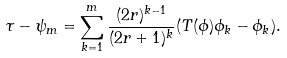<formula> <loc_0><loc_0><loc_500><loc_500>\tau - \psi _ { m } = \sum _ { k = 1 } ^ { m } \frac { ( 2 r ) ^ { k - 1 } } { ( 2 r + 1 ) ^ { k } } ( T ( \phi ) \phi _ { k } - \phi _ { k } ) .</formula> 